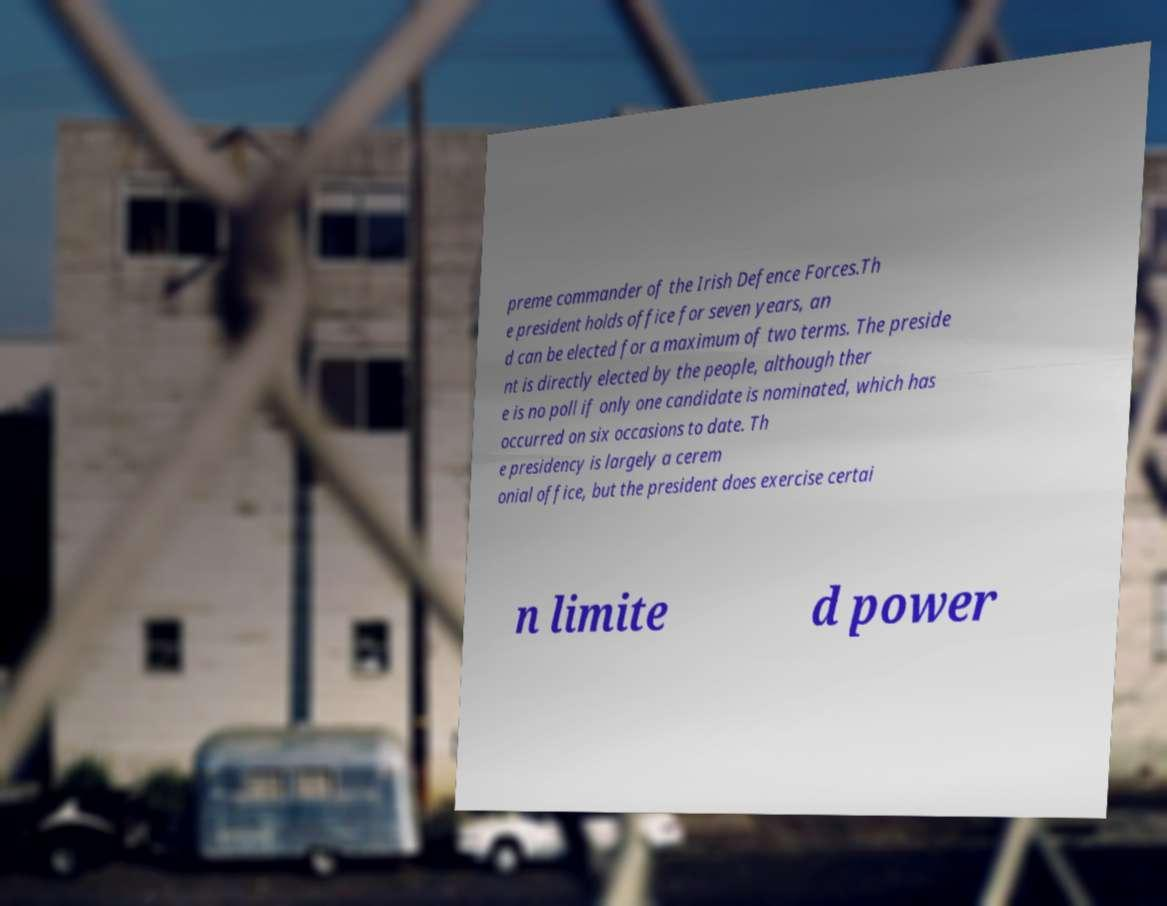There's text embedded in this image that I need extracted. Can you transcribe it verbatim? preme commander of the Irish Defence Forces.Th e president holds office for seven years, an d can be elected for a maximum of two terms. The preside nt is directly elected by the people, although ther e is no poll if only one candidate is nominated, which has occurred on six occasions to date. Th e presidency is largely a cerem onial office, but the president does exercise certai n limite d power 